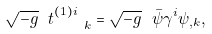Convert formula to latex. <formula><loc_0><loc_0><loc_500><loc_500>\sqrt { - g } \ t ^ { ( 1 ) i } _ { \quad k } = \sqrt { - g } \ \bar { \psi } \gamma ^ { i } \psi _ { , k } ,</formula> 